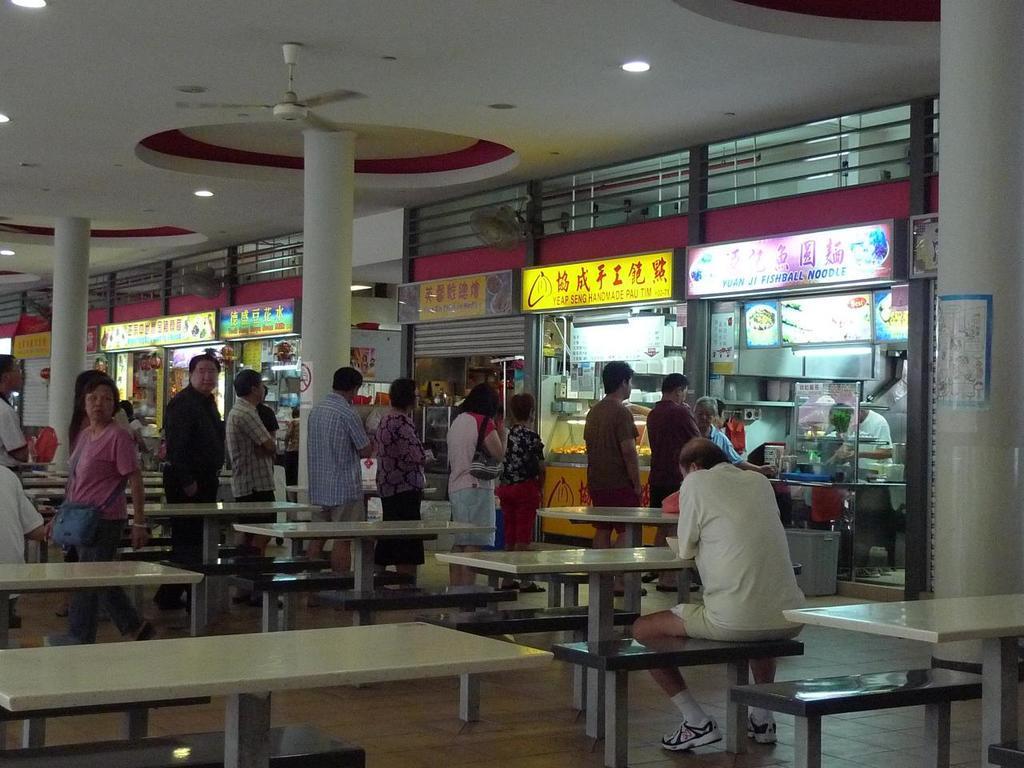Please provide a concise description of this image. In this Image I see people who are standing in line and I see this man is sitting on the bench and there are many more benches and tables and I see there are number of shops and on the ceiling I see the lights and a fan over here. 